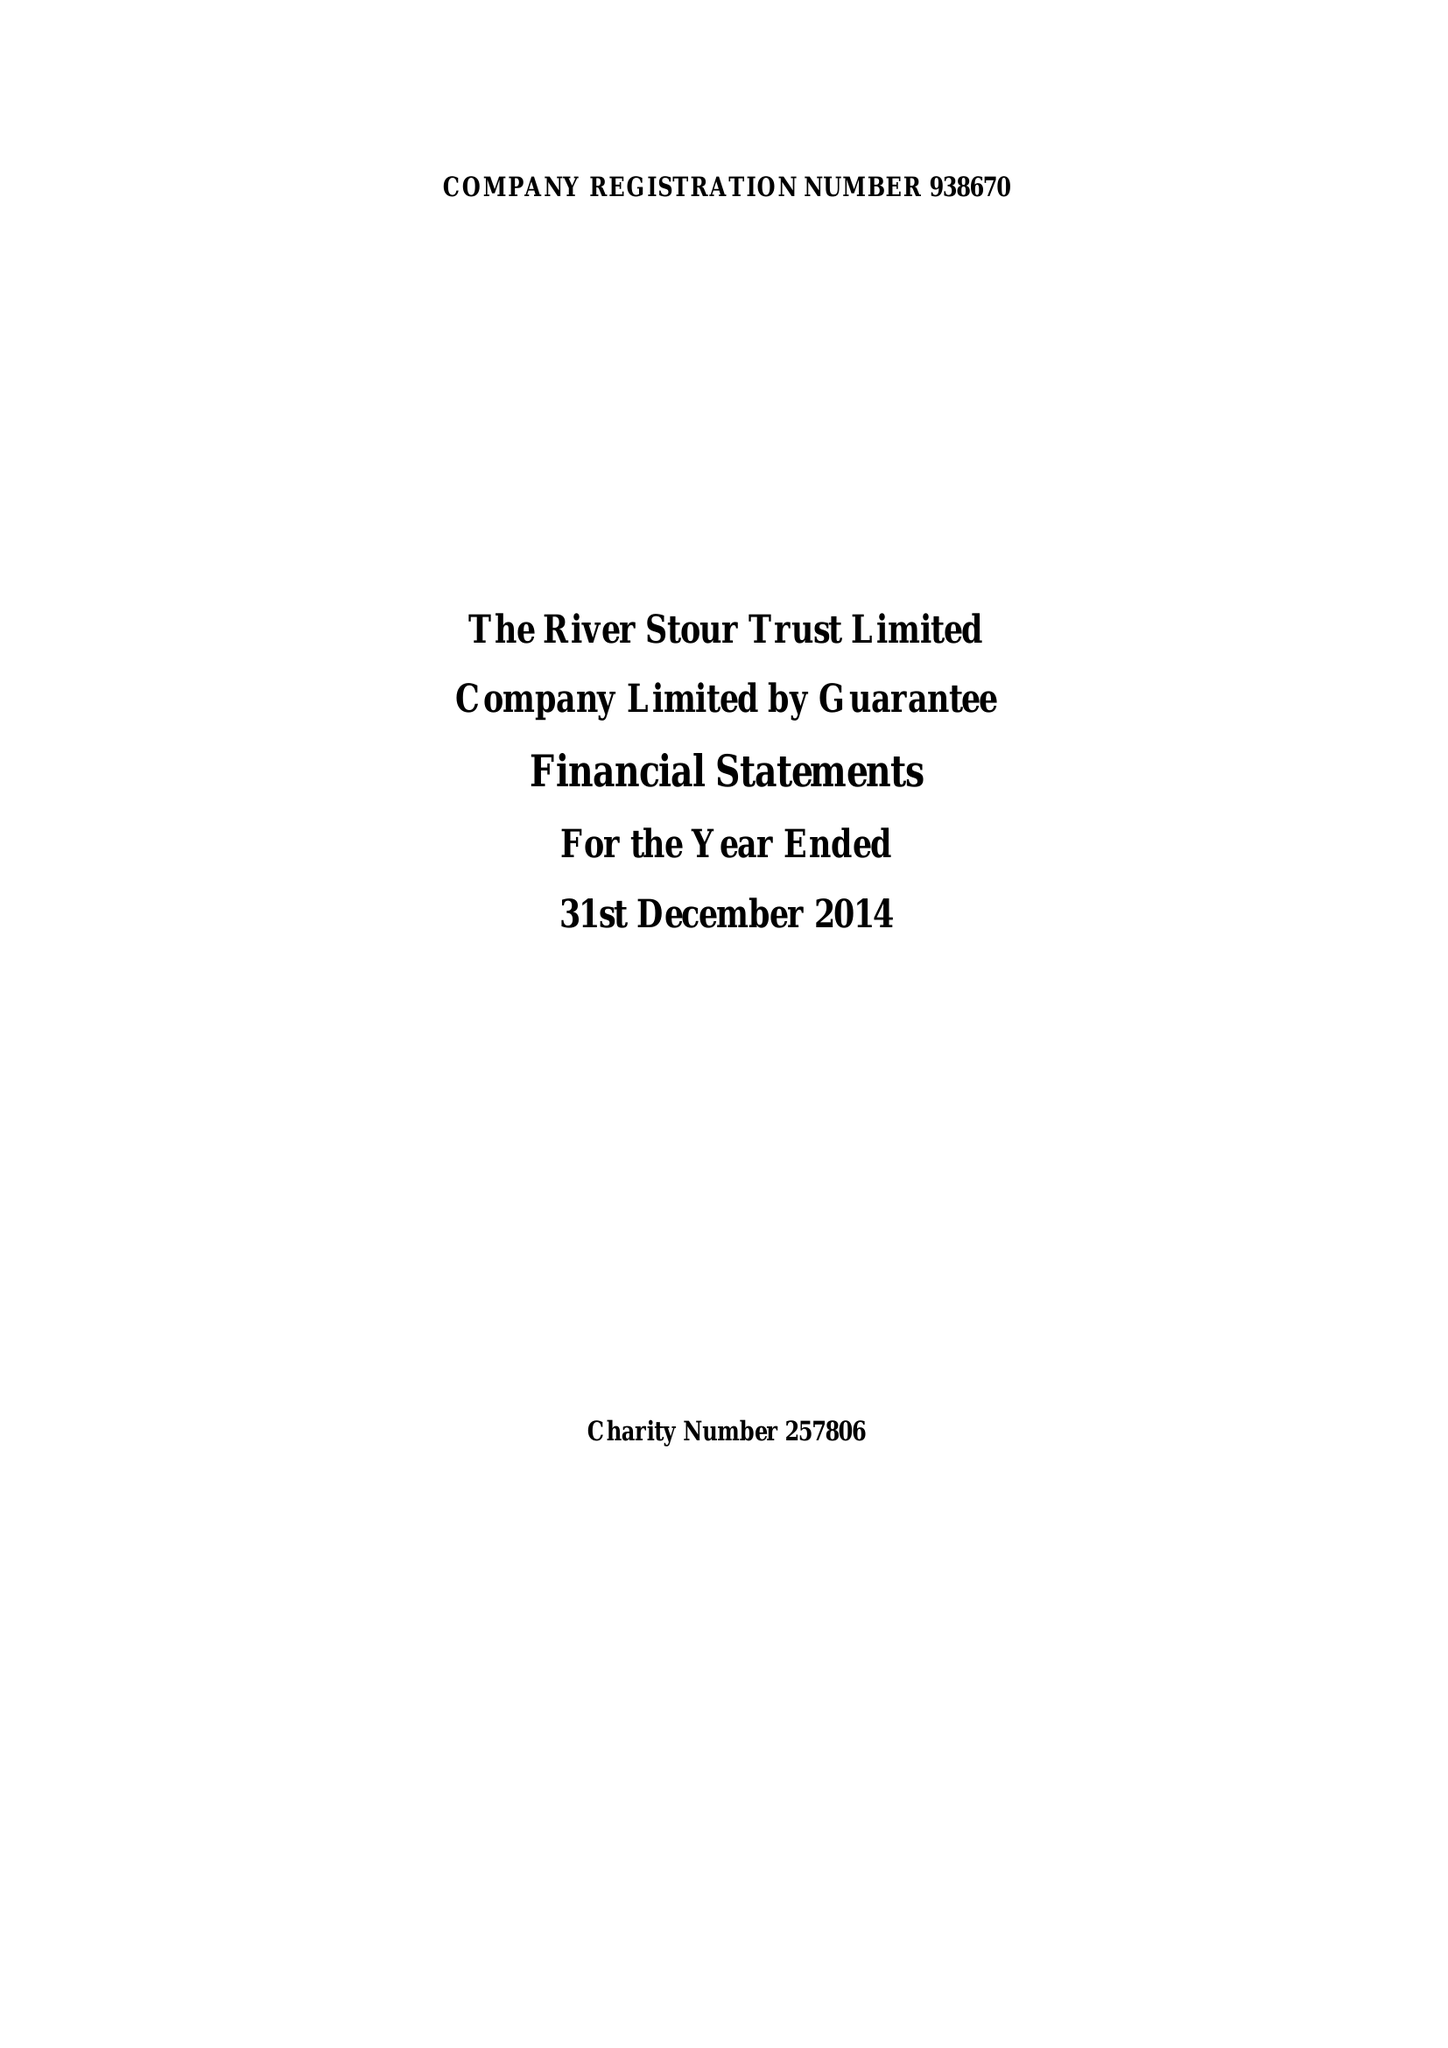What is the value for the address__post_town?
Answer the question using a single word or phrase. SUDBURY 